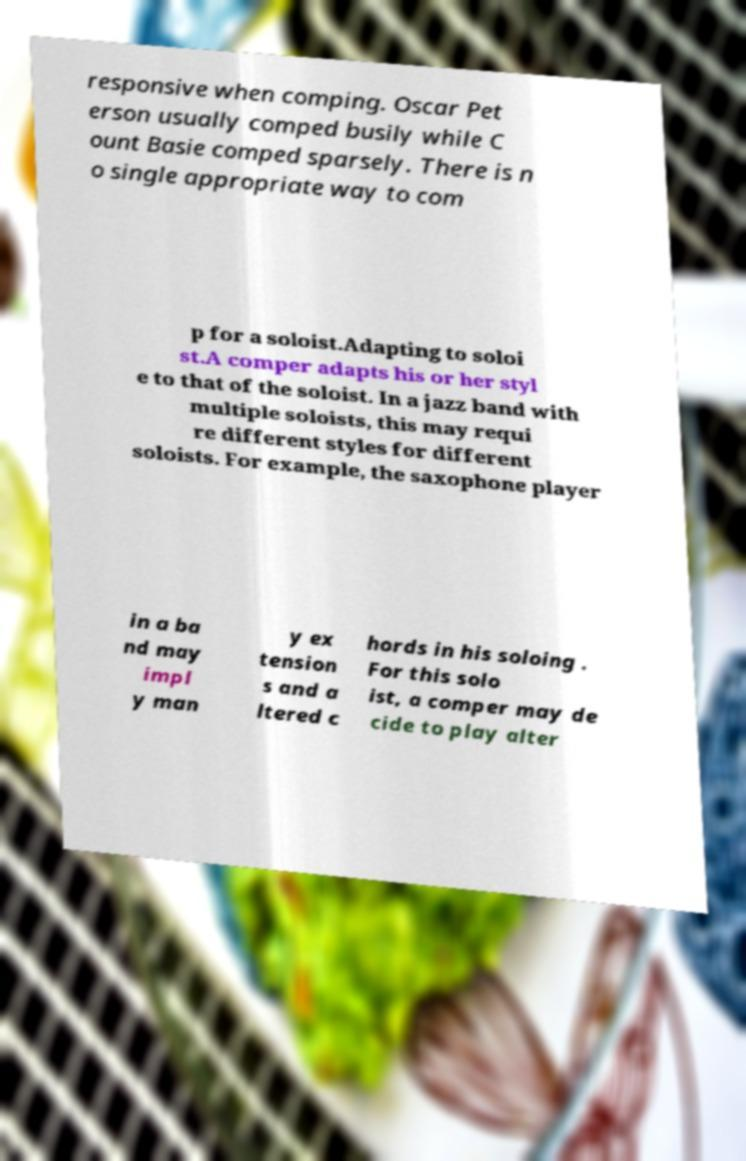What messages or text are displayed in this image? I need them in a readable, typed format. responsive when comping. Oscar Pet erson usually comped busily while C ount Basie comped sparsely. There is n o single appropriate way to com p for a soloist.Adapting to soloi st.A comper adapts his or her styl e to that of the soloist. In a jazz band with multiple soloists, this may requi re different styles for different soloists. For example, the saxophone player in a ba nd may impl y man y ex tension s and a ltered c hords in his soloing . For this solo ist, a comper may de cide to play alter 